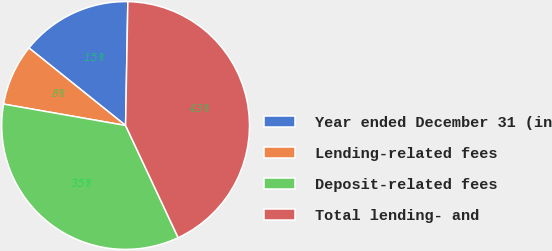<chart> <loc_0><loc_0><loc_500><loc_500><pie_chart><fcel>Year ended December 31 (in<fcel>Lending-related fees<fcel>Deposit-related fees<fcel>Total lending- and<nl><fcel>14.53%<fcel>8.0%<fcel>34.74%<fcel>42.74%<nl></chart> 